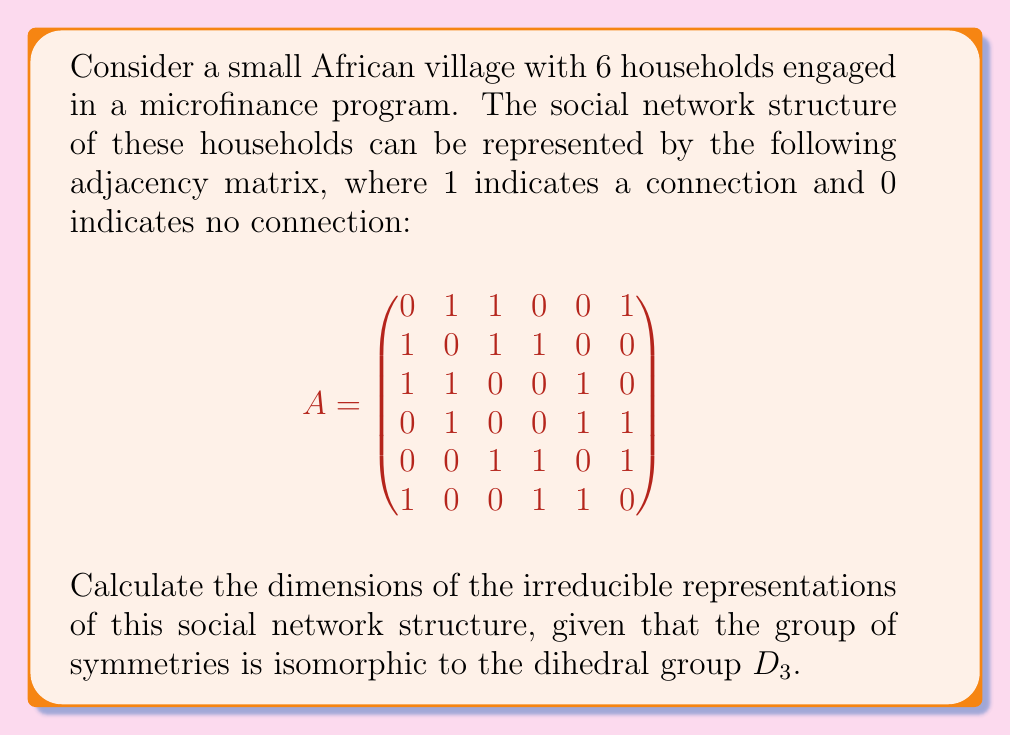Teach me how to tackle this problem. To find the dimensions of the irreducible representations, we'll follow these steps:

1) First, recall that the dihedral group $D_3$ has 6 elements and 3 conjugacy classes.

2) The number of irreducible representations is equal to the number of conjugacy classes. So, we have 3 irreducible representations.

3) For $D_3$, we know the character table:

   $$
   \begin{array}{c|ccc}
    D_3 & 1 & 3 & 2 \\
   \hline
   \chi_1 & 1 & 1 & 1 \\
   \chi_2 & 1 & -1 & 1 \\
   \chi_3 & 2 & 0 & -1
   \end{array}
   $$

4) The dimensions of the irreducible representations are given by the characters of the identity element (first column).

5) Therefore, the dimensions of the irreducible representations are 1, 1, and 2.

6) We can verify this using the formula:

   $$ \sum_{i=1}^k n_i^2 = |G| $$

   where $n_i$ are the dimensions of the irreducible representations and $|G|$ is the order of the group.

7) Indeed: $1^2 + 1^2 + 2^2 = 1 + 1 + 4 = 6 = |D_3|$

Thus, we have confirmed that the dimensions of the irreducible representations are correct.
Answer: 1, 1, 2 